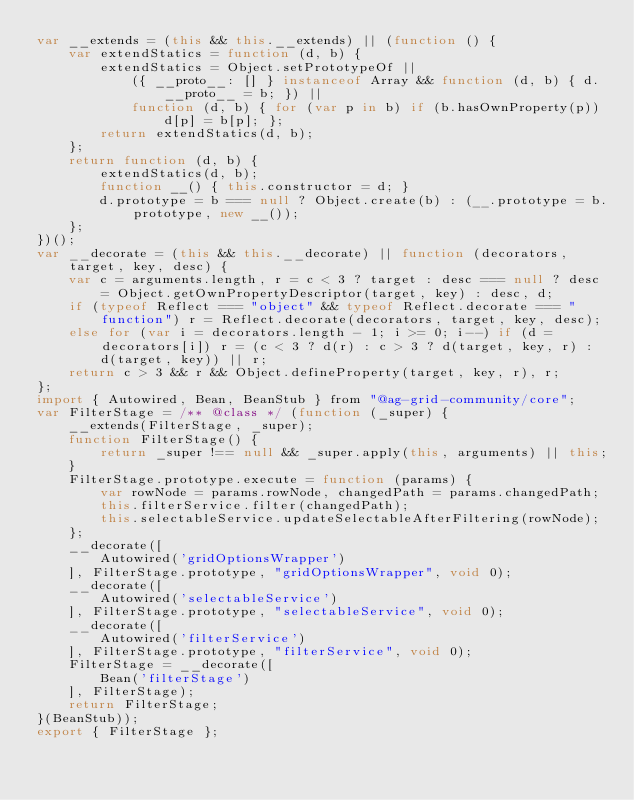<code> <loc_0><loc_0><loc_500><loc_500><_JavaScript_>var __extends = (this && this.__extends) || (function () {
    var extendStatics = function (d, b) {
        extendStatics = Object.setPrototypeOf ||
            ({ __proto__: [] } instanceof Array && function (d, b) { d.__proto__ = b; }) ||
            function (d, b) { for (var p in b) if (b.hasOwnProperty(p)) d[p] = b[p]; };
        return extendStatics(d, b);
    };
    return function (d, b) {
        extendStatics(d, b);
        function __() { this.constructor = d; }
        d.prototype = b === null ? Object.create(b) : (__.prototype = b.prototype, new __());
    };
})();
var __decorate = (this && this.__decorate) || function (decorators, target, key, desc) {
    var c = arguments.length, r = c < 3 ? target : desc === null ? desc = Object.getOwnPropertyDescriptor(target, key) : desc, d;
    if (typeof Reflect === "object" && typeof Reflect.decorate === "function") r = Reflect.decorate(decorators, target, key, desc);
    else for (var i = decorators.length - 1; i >= 0; i--) if (d = decorators[i]) r = (c < 3 ? d(r) : c > 3 ? d(target, key, r) : d(target, key)) || r;
    return c > 3 && r && Object.defineProperty(target, key, r), r;
};
import { Autowired, Bean, BeanStub } from "@ag-grid-community/core";
var FilterStage = /** @class */ (function (_super) {
    __extends(FilterStage, _super);
    function FilterStage() {
        return _super !== null && _super.apply(this, arguments) || this;
    }
    FilterStage.prototype.execute = function (params) {
        var rowNode = params.rowNode, changedPath = params.changedPath;
        this.filterService.filter(changedPath);
        this.selectableService.updateSelectableAfterFiltering(rowNode);
    };
    __decorate([
        Autowired('gridOptionsWrapper')
    ], FilterStage.prototype, "gridOptionsWrapper", void 0);
    __decorate([
        Autowired('selectableService')
    ], FilterStage.prototype, "selectableService", void 0);
    __decorate([
        Autowired('filterService')
    ], FilterStage.prototype, "filterService", void 0);
    FilterStage = __decorate([
        Bean('filterStage')
    ], FilterStage);
    return FilterStage;
}(BeanStub));
export { FilterStage };
</code> 